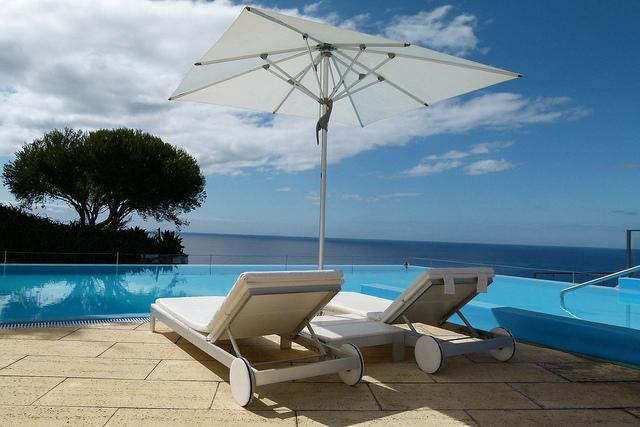What would a person be doing here? Please explain your reasoning. relaxing. The area looks like a vocational facility where a person would go to relax. 